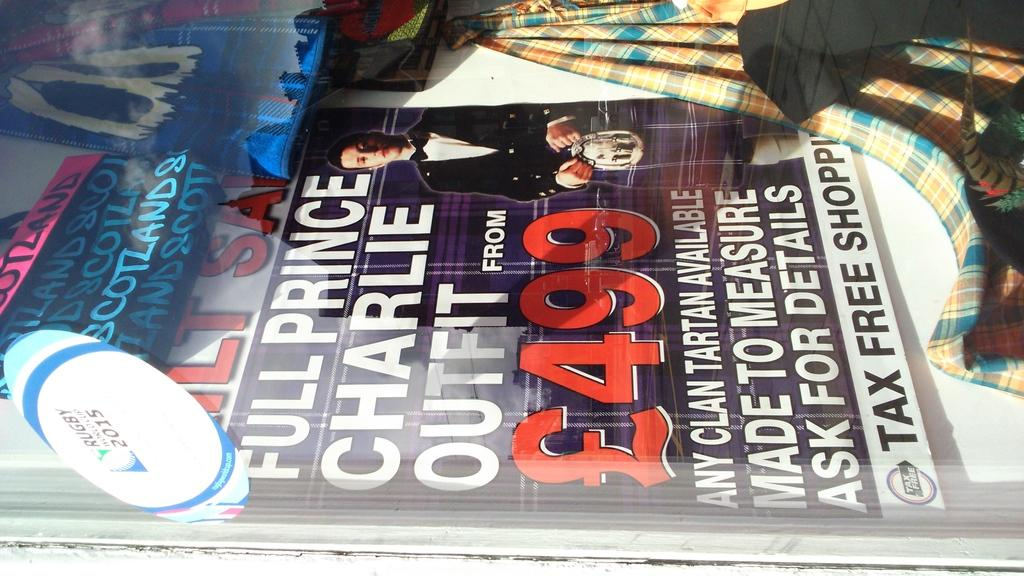<image>
Offer a succinct explanation of the picture presented. A magazine featuring Full Prince Charlie Outfit from L499. 